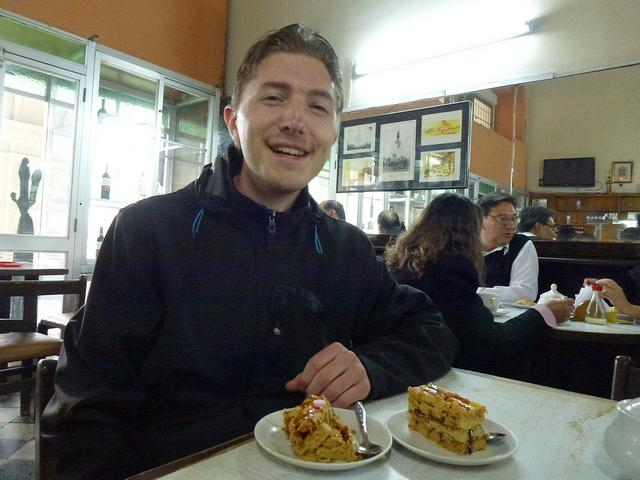What type food is this man enjoying? Please explain your reasoning. dessert food. The item being eaten is solid, not liquid. the man is enjoying a cake, not a pizza or salad. 